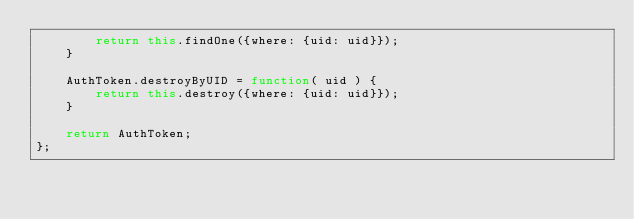Convert code to text. <code><loc_0><loc_0><loc_500><loc_500><_JavaScript_>		return this.findOne({where: {uid: uid}});
	}
	
	AuthToken.destroyByUID = function( uid ) {
		return this.destroy({where: {uid: uid}});
	}

	return AuthToken;
};
</code> 